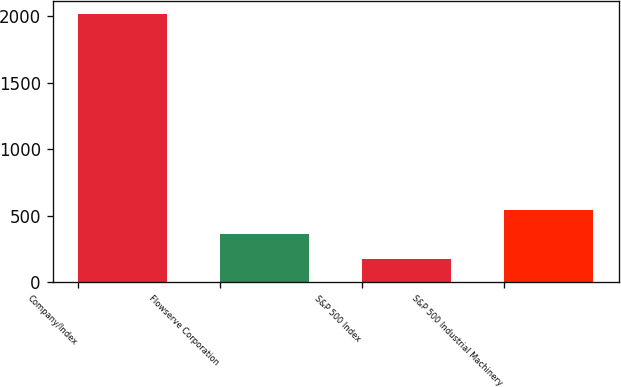Convert chart. <chart><loc_0><loc_0><loc_500><loc_500><bar_chart><fcel>Company/Index<fcel>Flowserve Corporation<fcel>S&P 500 Index<fcel>S&P 500 Industrial Machinery<nl><fcel>2014<fcel>358.49<fcel>174.54<fcel>542.44<nl></chart> 